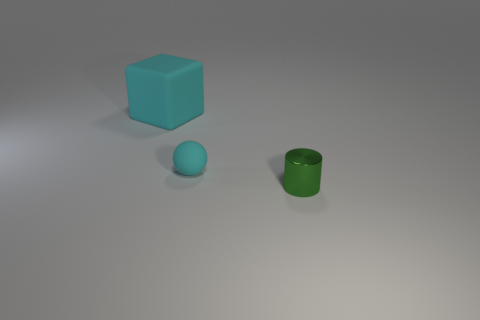Add 1 brown matte objects. How many objects exist? 4 Subtract all balls. How many objects are left? 2 Subtract all gray spheres. How many green cubes are left? 0 Subtract all large purple cylinders. Subtract all matte balls. How many objects are left? 2 Add 3 metallic cylinders. How many metallic cylinders are left? 4 Add 3 brown rubber spheres. How many brown rubber spheres exist? 3 Subtract 0 yellow cylinders. How many objects are left? 3 